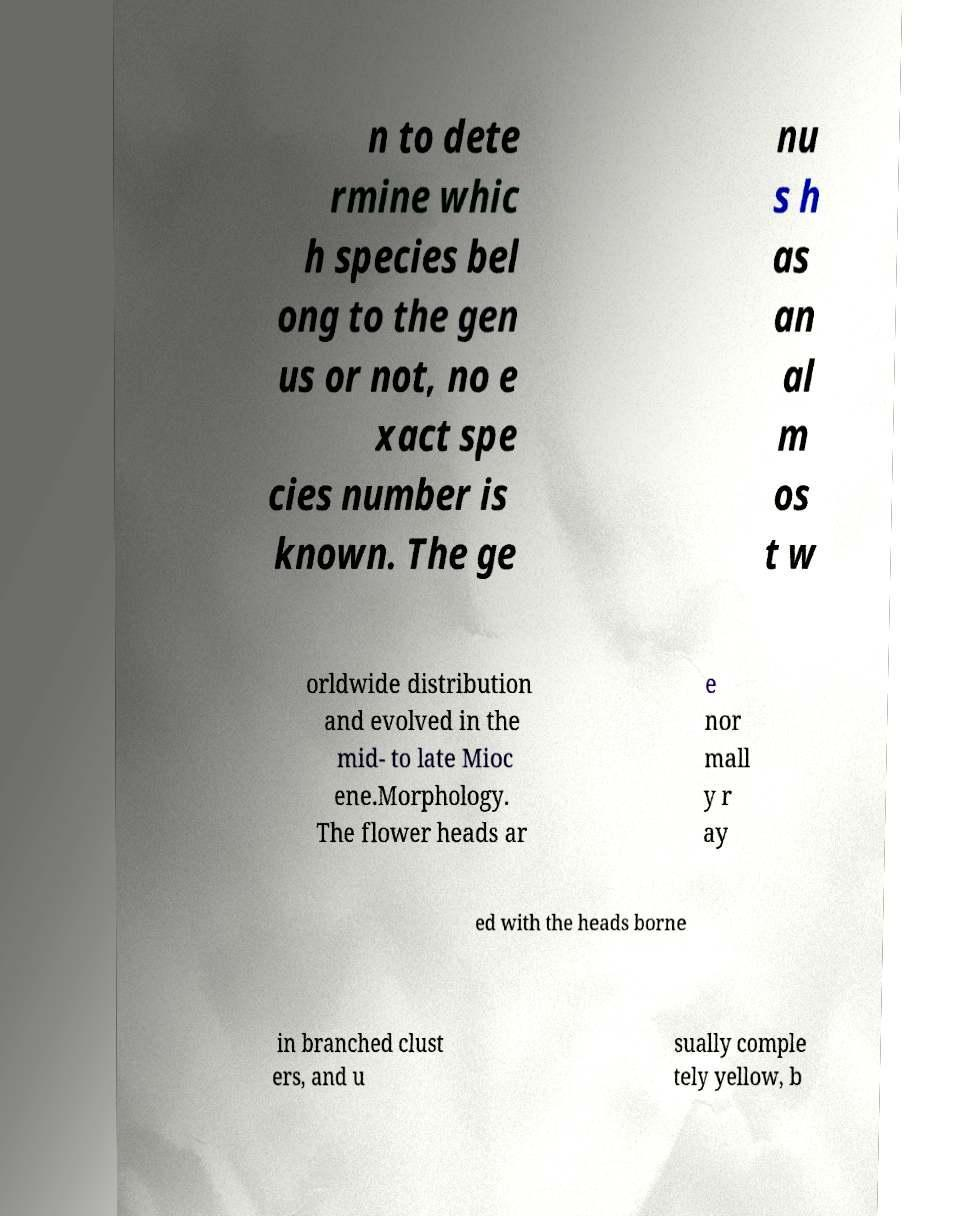I need the written content from this picture converted into text. Can you do that? n to dete rmine whic h species bel ong to the gen us or not, no e xact spe cies number is known. The ge nu s h as an al m os t w orldwide distribution and evolved in the mid- to late Mioc ene.Morphology. The flower heads ar e nor mall y r ay ed with the heads borne in branched clust ers, and u sually comple tely yellow, b 